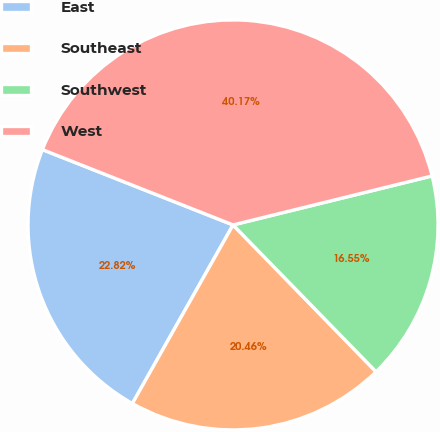Convert chart to OTSL. <chart><loc_0><loc_0><loc_500><loc_500><pie_chart><fcel>East<fcel>Southeast<fcel>Southwest<fcel>West<nl><fcel>22.82%<fcel>20.46%<fcel>16.55%<fcel>40.17%<nl></chart> 